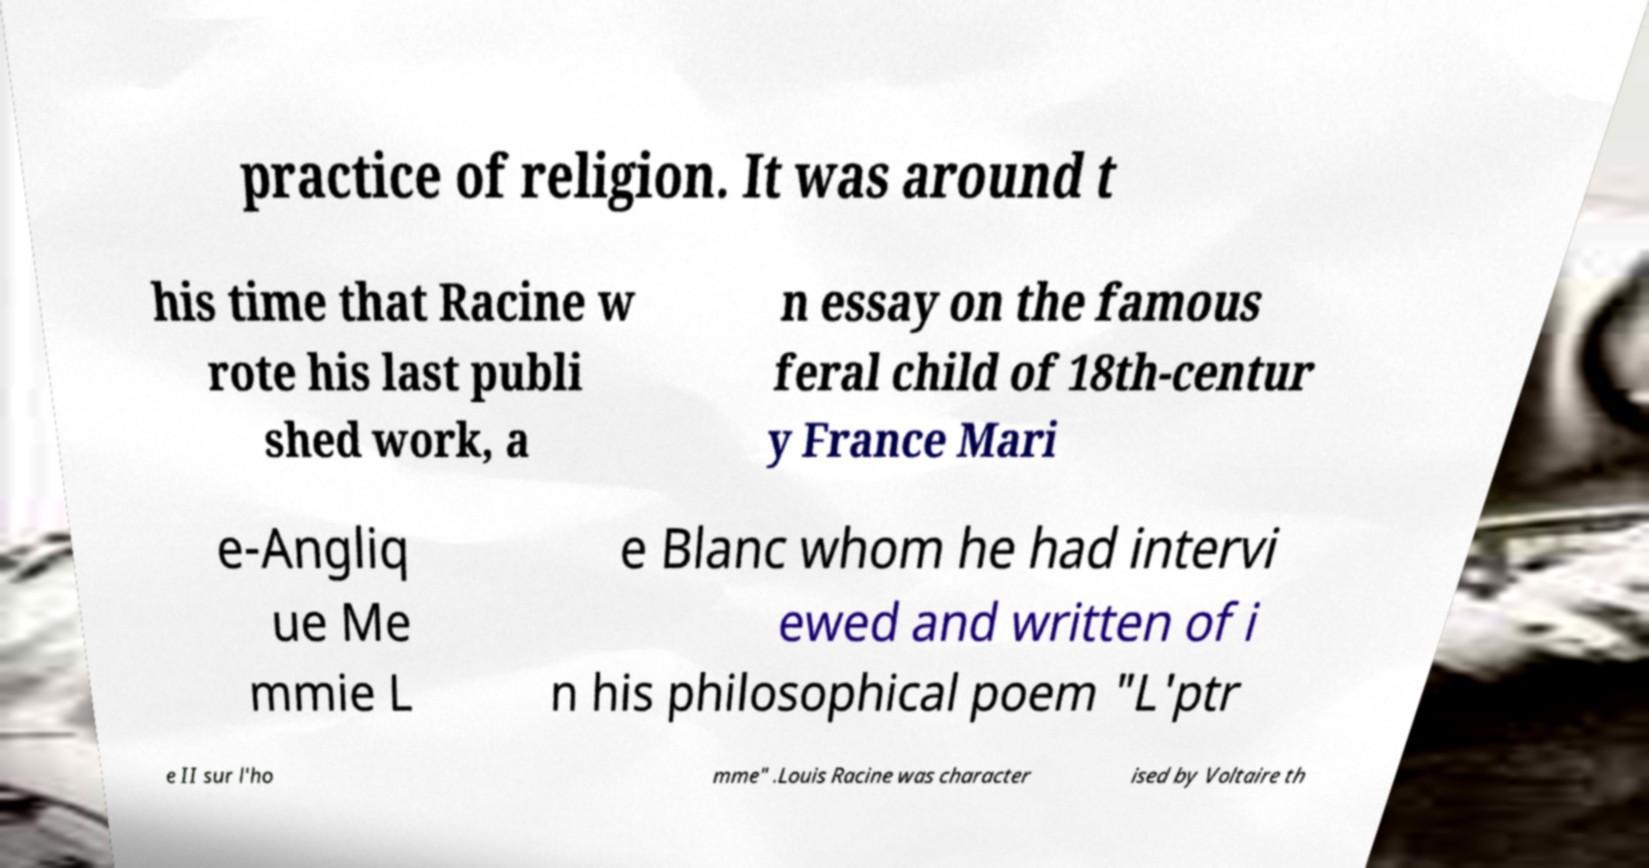For documentation purposes, I need the text within this image transcribed. Could you provide that? practice of religion. It was around t his time that Racine w rote his last publi shed work, a n essay on the famous feral child of 18th-centur y France Mari e-Angliq ue Me mmie L e Blanc whom he had intervi ewed and written of i n his philosophical poem "L'ptr e II sur l'ho mme" .Louis Racine was character ised by Voltaire th 